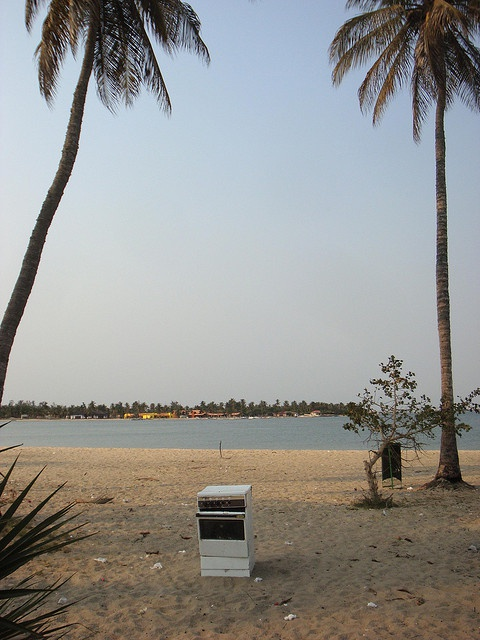Describe the objects in this image and their specific colors. I can see a oven in lightgray, gray, black, and darkgray tones in this image. 